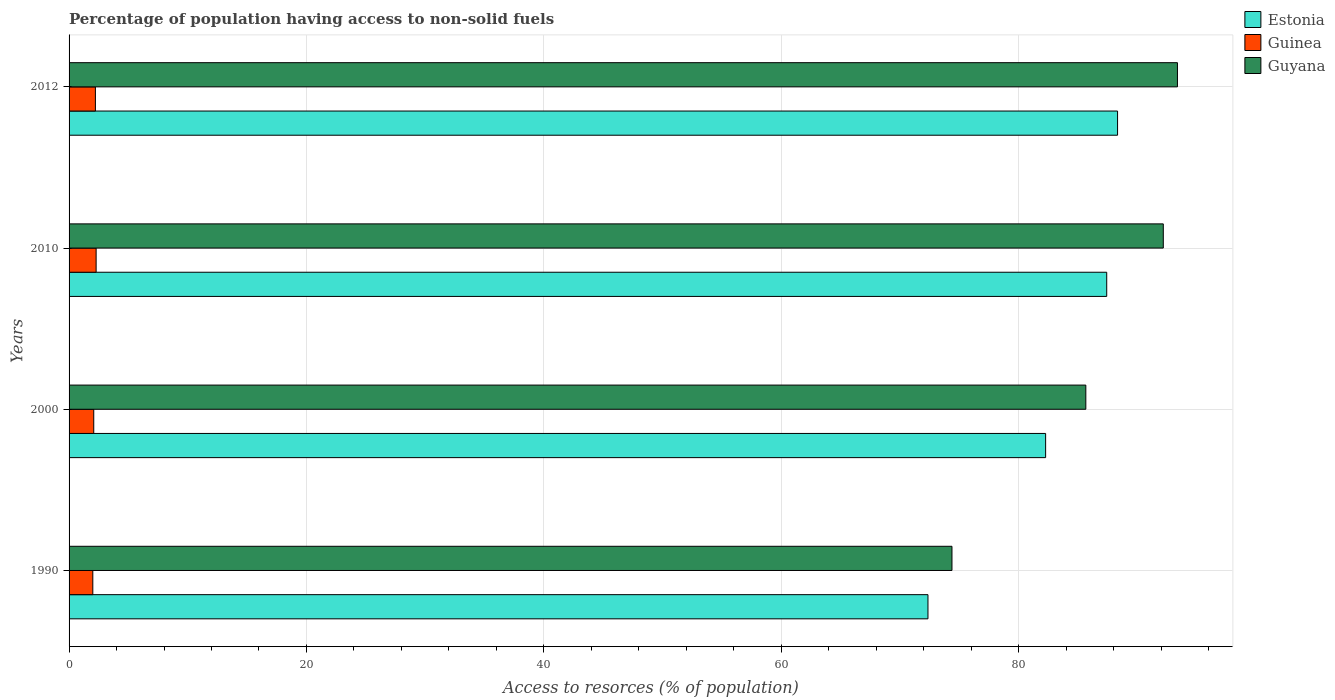How many different coloured bars are there?
Your answer should be compact. 3. How many groups of bars are there?
Your response must be concise. 4. Are the number of bars on each tick of the Y-axis equal?
Your answer should be very brief. Yes. How many bars are there on the 3rd tick from the top?
Offer a very short reply. 3. How many bars are there on the 3rd tick from the bottom?
Offer a terse response. 3. In how many cases, is the number of bars for a given year not equal to the number of legend labels?
Your response must be concise. 0. What is the percentage of population having access to non-solid fuels in Guinea in 2010?
Offer a very short reply. 2.28. Across all years, what is the maximum percentage of population having access to non-solid fuels in Estonia?
Give a very brief answer. 88.34. Across all years, what is the minimum percentage of population having access to non-solid fuels in Guyana?
Your response must be concise. 74.39. In which year was the percentage of population having access to non-solid fuels in Guyana maximum?
Provide a succinct answer. 2012. What is the total percentage of population having access to non-solid fuels in Estonia in the graph?
Offer a very short reply. 330.4. What is the difference between the percentage of population having access to non-solid fuels in Estonia in 2000 and that in 2010?
Your answer should be very brief. -5.15. What is the difference between the percentage of population having access to non-solid fuels in Guyana in 1990 and the percentage of population having access to non-solid fuels in Guinea in 2010?
Provide a succinct answer. 72.11. What is the average percentage of population having access to non-solid fuels in Guinea per year?
Your response must be concise. 2.14. In the year 2000, what is the difference between the percentage of population having access to non-solid fuels in Guyana and percentage of population having access to non-solid fuels in Estonia?
Your response must be concise. 3.39. In how many years, is the percentage of population having access to non-solid fuels in Estonia greater than 68 %?
Ensure brevity in your answer.  4. What is the ratio of the percentage of population having access to non-solid fuels in Guinea in 1990 to that in 2000?
Your answer should be compact. 0.96. Is the difference between the percentage of population having access to non-solid fuels in Guyana in 1990 and 2010 greater than the difference between the percentage of population having access to non-solid fuels in Estonia in 1990 and 2010?
Provide a short and direct response. No. What is the difference between the highest and the second highest percentage of population having access to non-solid fuels in Guyana?
Give a very brief answer. 1.19. What is the difference between the highest and the lowest percentage of population having access to non-solid fuels in Guinea?
Give a very brief answer. 0.28. In how many years, is the percentage of population having access to non-solid fuels in Estonia greater than the average percentage of population having access to non-solid fuels in Estonia taken over all years?
Provide a short and direct response. 2. Is the sum of the percentage of population having access to non-solid fuels in Guinea in 2000 and 2012 greater than the maximum percentage of population having access to non-solid fuels in Guyana across all years?
Make the answer very short. No. What does the 2nd bar from the top in 2012 represents?
Offer a terse response. Guinea. What does the 2nd bar from the bottom in 2010 represents?
Offer a terse response. Guinea. How many bars are there?
Your answer should be compact. 12. Are all the bars in the graph horizontal?
Your answer should be very brief. Yes. How many years are there in the graph?
Offer a very short reply. 4. What is the difference between two consecutive major ticks on the X-axis?
Your answer should be compact. 20. Are the values on the major ticks of X-axis written in scientific E-notation?
Give a very brief answer. No. Does the graph contain any zero values?
Provide a short and direct response. No. Does the graph contain grids?
Ensure brevity in your answer.  Yes. How many legend labels are there?
Your response must be concise. 3. How are the legend labels stacked?
Provide a succinct answer. Vertical. What is the title of the graph?
Your answer should be compact. Percentage of population having access to non-solid fuels. Does "Serbia" appear as one of the legend labels in the graph?
Keep it short and to the point. No. What is the label or title of the X-axis?
Your response must be concise. Access to resorces (% of population). What is the label or title of the Y-axis?
Offer a very short reply. Years. What is the Access to resorces (% of population) in Estonia in 1990?
Your response must be concise. 72.36. What is the Access to resorces (% of population) in Guinea in 1990?
Provide a succinct answer. 2. What is the Access to resorces (% of population) in Guyana in 1990?
Offer a terse response. 74.39. What is the Access to resorces (% of population) in Estonia in 2000?
Offer a terse response. 82.28. What is the Access to resorces (% of population) in Guinea in 2000?
Ensure brevity in your answer.  2.08. What is the Access to resorces (% of population) in Guyana in 2000?
Provide a succinct answer. 85.66. What is the Access to resorces (% of population) of Estonia in 2010?
Your answer should be compact. 87.42. What is the Access to resorces (% of population) of Guinea in 2010?
Provide a succinct answer. 2.28. What is the Access to resorces (% of population) in Guyana in 2010?
Provide a succinct answer. 92.19. What is the Access to resorces (% of population) of Estonia in 2012?
Ensure brevity in your answer.  88.34. What is the Access to resorces (% of population) of Guinea in 2012?
Make the answer very short. 2.22. What is the Access to resorces (% of population) in Guyana in 2012?
Give a very brief answer. 93.38. Across all years, what is the maximum Access to resorces (% of population) of Estonia?
Provide a succinct answer. 88.34. Across all years, what is the maximum Access to resorces (% of population) of Guinea?
Offer a very short reply. 2.28. Across all years, what is the maximum Access to resorces (% of population) of Guyana?
Offer a terse response. 93.38. Across all years, what is the minimum Access to resorces (% of population) in Estonia?
Give a very brief answer. 72.36. Across all years, what is the minimum Access to resorces (% of population) of Guinea?
Your answer should be very brief. 2. Across all years, what is the minimum Access to resorces (% of population) of Guyana?
Keep it short and to the point. 74.39. What is the total Access to resorces (% of population) of Estonia in the graph?
Provide a succinct answer. 330.4. What is the total Access to resorces (% of population) in Guinea in the graph?
Your response must be concise. 8.58. What is the total Access to resorces (% of population) of Guyana in the graph?
Your response must be concise. 345.62. What is the difference between the Access to resorces (% of population) of Estonia in 1990 and that in 2000?
Offer a very short reply. -9.91. What is the difference between the Access to resorces (% of population) of Guinea in 1990 and that in 2000?
Give a very brief answer. -0.08. What is the difference between the Access to resorces (% of population) in Guyana in 1990 and that in 2000?
Offer a terse response. -11.28. What is the difference between the Access to resorces (% of population) in Estonia in 1990 and that in 2010?
Your answer should be compact. -15.06. What is the difference between the Access to resorces (% of population) of Guinea in 1990 and that in 2010?
Give a very brief answer. -0.28. What is the difference between the Access to resorces (% of population) in Guyana in 1990 and that in 2010?
Give a very brief answer. -17.8. What is the difference between the Access to resorces (% of population) of Estonia in 1990 and that in 2012?
Provide a succinct answer. -15.97. What is the difference between the Access to resorces (% of population) of Guinea in 1990 and that in 2012?
Make the answer very short. -0.22. What is the difference between the Access to resorces (% of population) in Guyana in 1990 and that in 2012?
Offer a very short reply. -19. What is the difference between the Access to resorces (% of population) in Estonia in 2000 and that in 2010?
Make the answer very short. -5.15. What is the difference between the Access to resorces (% of population) of Guinea in 2000 and that in 2010?
Provide a succinct answer. -0.2. What is the difference between the Access to resorces (% of population) of Guyana in 2000 and that in 2010?
Your answer should be compact. -6.53. What is the difference between the Access to resorces (% of population) of Estonia in 2000 and that in 2012?
Your answer should be compact. -6.06. What is the difference between the Access to resorces (% of population) in Guinea in 2000 and that in 2012?
Offer a terse response. -0.14. What is the difference between the Access to resorces (% of population) in Guyana in 2000 and that in 2012?
Make the answer very short. -7.72. What is the difference between the Access to resorces (% of population) in Estonia in 2010 and that in 2012?
Keep it short and to the point. -0.91. What is the difference between the Access to resorces (% of population) in Guinea in 2010 and that in 2012?
Offer a very short reply. 0.06. What is the difference between the Access to resorces (% of population) of Guyana in 2010 and that in 2012?
Provide a succinct answer. -1.19. What is the difference between the Access to resorces (% of population) in Estonia in 1990 and the Access to resorces (% of population) in Guinea in 2000?
Provide a short and direct response. 70.28. What is the difference between the Access to resorces (% of population) in Estonia in 1990 and the Access to resorces (% of population) in Guyana in 2000?
Provide a short and direct response. -13.3. What is the difference between the Access to resorces (% of population) of Guinea in 1990 and the Access to resorces (% of population) of Guyana in 2000?
Ensure brevity in your answer.  -83.66. What is the difference between the Access to resorces (% of population) of Estonia in 1990 and the Access to resorces (% of population) of Guinea in 2010?
Give a very brief answer. 70.08. What is the difference between the Access to resorces (% of population) of Estonia in 1990 and the Access to resorces (% of population) of Guyana in 2010?
Make the answer very short. -19.83. What is the difference between the Access to resorces (% of population) in Guinea in 1990 and the Access to resorces (% of population) in Guyana in 2010?
Make the answer very short. -90.19. What is the difference between the Access to resorces (% of population) in Estonia in 1990 and the Access to resorces (% of population) in Guinea in 2012?
Provide a succinct answer. 70.15. What is the difference between the Access to resorces (% of population) of Estonia in 1990 and the Access to resorces (% of population) of Guyana in 2012?
Ensure brevity in your answer.  -21.02. What is the difference between the Access to resorces (% of population) in Guinea in 1990 and the Access to resorces (% of population) in Guyana in 2012?
Ensure brevity in your answer.  -91.38. What is the difference between the Access to resorces (% of population) of Estonia in 2000 and the Access to resorces (% of population) of Guinea in 2010?
Keep it short and to the point. 80. What is the difference between the Access to resorces (% of population) in Estonia in 2000 and the Access to resorces (% of population) in Guyana in 2010?
Ensure brevity in your answer.  -9.91. What is the difference between the Access to resorces (% of population) of Guinea in 2000 and the Access to resorces (% of population) of Guyana in 2010?
Offer a very short reply. -90.11. What is the difference between the Access to resorces (% of population) in Estonia in 2000 and the Access to resorces (% of population) in Guinea in 2012?
Offer a terse response. 80.06. What is the difference between the Access to resorces (% of population) of Estonia in 2000 and the Access to resorces (% of population) of Guyana in 2012?
Keep it short and to the point. -11.11. What is the difference between the Access to resorces (% of population) of Guinea in 2000 and the Access to resorces (% of population) of Guyana in 2012?
Provide a succinct answer. -91.3. What is the difference between the Access to resorces (% of population) of Estonia in 2010 and the Access to resorces (% of population) of Guinea in 2012?
Make the answer very short. 85.2. What is the difference between the Access to resorces (% of population) of Estonia in 2010 and the Access to resorces (% of population) of Guyana in 2012?
Provide a short and direct response. -5.96. What is the difference between the Access to resorces (% of population) of Guinea in 2010 and the Access to resorces (% of population) of Guyana in 2012?
Give a very brief answer. -91.1. What is the average Access to resorces (% of population) in Estonia per year?
Provide a succinct answer. 82.6. What is the average Access to resorces (% of population) of Guinea per year?
Provide a succinct answer. 2.14. What is the average Access to resorces (% of population) in Guyana per year?
Your response must be concise. 86.41. In the year 1990, what is the difference between the Access to resorces (% of population) of Estonia and Access to resorces (% of population) of Guinea?
Provide a succinct answer. 70.36. In the year 1990, what is the difference between the Access to resorces (% of population) in Estonia and Access to resorces (% of population) in Guyana?
Keep it short and to the point. -2.02. In the year 1990, what is the difference between the Access to resorces (% of population) of Guinea and Access to resorces (% of population) of Guyana?
Offer a terse response. -72.39. In the year 2000, what is the difference between the Access to resorces (% of population) of Estonia and Access to resorces (% of population) of Guinea?
Provide a short and direct response. 80.2. In the year 2000, what is the difference between the Access to resorces (% of population) of Estonia and Access to resorces (% of population) of Guyana?
Your answer should be compact. -3.39. In the year 2000, what is the difference between the Access to resorces (% of population) in Guinea and Access to resorces (% of population) in Guyana?
Your answer should be compact. -83.58. In the year 2010, what is the difference between the Access to resorces (% of population) in Estonia and Access to resorces (% of population) in Guinea?
Offer a terse response. 85.14. In the year 2010, what is the difference between the Access to resorces (% of population) in Estonia and Access to resorces (% of population) in Guyana?
Ensure brevity in your answer.  -4.77. In the year 2010, what is the difference between the Access to resorces (% of population) of Guinea and Access to resorces (% of population) of Guyana?
Your answer should be very brief. -89.91. In the year 2012, what is the difference between the Access to resorces (% of population) in Estonia and Access to resorces (% of population) in Guinea?
Ensure brevity in your answer.  86.12. In the year 2012, what is the difference between the Access to resorces (% of population) in Estonia and Access to resorces (% of population) in Guyana?
Give a very brief answer. -5.05. In the year 2012, what is the difference between the Access to resorces (% of population) of Guinea and Access to resorces (% of population) of Guyana?
Provide a succinct answer. -91.16. What is the ratio of the Access to resorces (% of population) of Estonia in 1990 to that in 2000?
Ensure brevity in your answer.  0.88. What is the ratio of the Access to resorces (% of population) in Guinea in 1990 to that in 2000?
Your response must be concise. 0.96. What is the ratio of the Access to resorces (% of population) of Guyana in 1990 to that in 2000?
Offer a terse response. 0.87. What is the ratio of the Access to resorces (% of population) in Estonia in 1990 to that in 2010?
Your answer should be compact. 0.83. What is the ratio of the Access to resorces (% of population) in Guinea in 1990 to that in 2010?
Offer a terse response. 0.88. What is the ratio of the Access to resorces (% of population) of Guyana in 1990 to that in 2010?
Offer a terse response. 0.81. What is the ratio of the Access to resorces (% of population) of Estonia in 1990 to that in 2012?
Ensure brevity in your answer.  0.82. What is the ratio of the Access to resorces (% of population) of Guinea in 1990 to that in 2012?
Ensure brevity in your answer.  0.9. What is the ratio of the Access to resorces (% of population) of Guyana in 1990 to that in 2012?
Give a very brief answer. 0.8. What is the ratio of the Access to resorces (% of population) in Estonia in 2000 to that in 2010?
Your answer should be very brief. 0.94. What is the ratio of the Access to resorces (% of population) of Guinea in 2000 to that in 2010?
Ensure brevity in your answer.  0.91. What is the ratio of the Access to resorces (% of population) of Guyana in 2000 to that in 2010?
Offer a very short reply. 0.93. What is the ratio of the Access to resorces (% of population) in Estonia in 2000 to that in 2012?
Offer a very short reply. 0.93. What is the ratio of the Access to resorces (% of population) of Guinea in 2000 to that in 2012?
Make the answer very short. 0.94. What is the ratio of the Access to resorces (% of population) of Guyana in 2000 to that in 2012?
Keep it short and to the point. 0.92. What is the ratio of the Access to resorces (% of population) of Estonia in 2010 to that in 2012?
Your answer should be compact. 0.99. What is the ratio of the Access to resorces (% of population) in Guinea in 2010 to that in 2012?
Your response must be concise. 1.03. What is the ratio of the Access to resorces (% of population) of Guyana in 2010 to that in 2012?
Keep it short and to the point. 0.99. What is the difference between the highest and the second highest Access to resorces (% of population) of Estonia?
Ensure brevity in your answer.  0.91. What is the difference between the highest and the second highest Access to resorces (% of population) of Guinea?
Provide a short and direct response. 0.06. What is the difference between the highest and the second highest Access to resorces (% of population) in Guyana?
Offer a terse response. 1.19. What is the difference between the highest and the lowest Access to resorces (% of population) in Estonia?
Offer a terse response. 15.97. What is the difference between the highest and the lowest Access to resorces (% of population) of Guinea?
Your answer should be compact. 0.28. What is the difference between the highest and the lowest Access to resorces (% of population) of Guyana?
Keep it short and to the point. 19. 